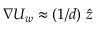Convert formula to latex. <formula><loc_0><loc_0><loc_500><loc_500>\nabla U _ { w } \approx ( 1 / d ) \ \hat { z }</formula> 